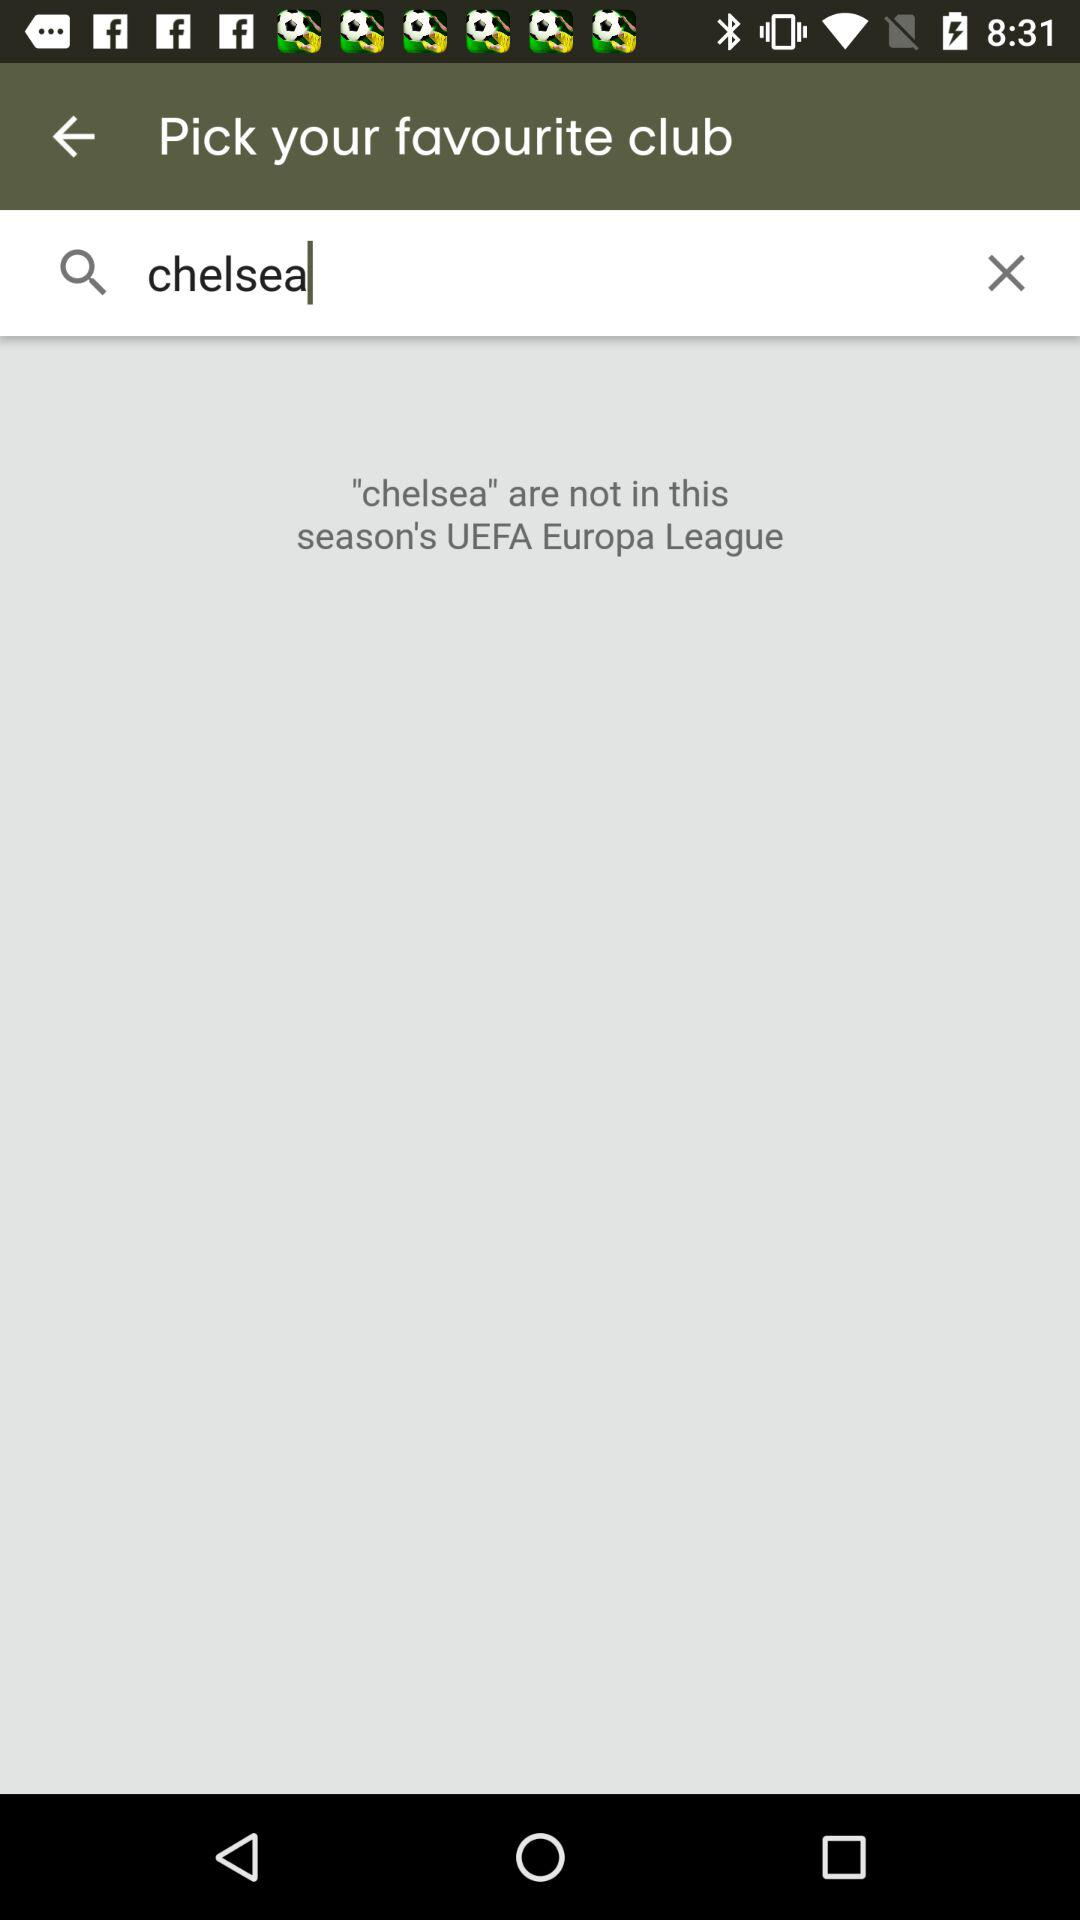What favourite club is searched?
Answer the question using a single word or phrase. The searched club is "chelsea" 